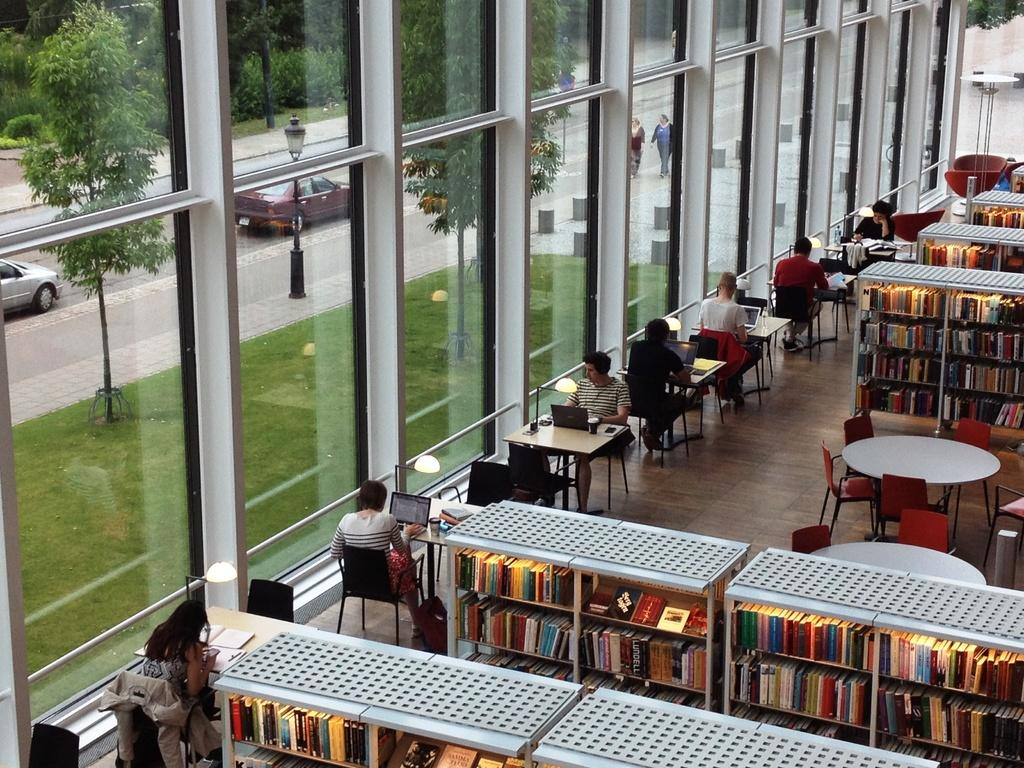What are the people in the image doing? The people in the image are sitting on chairs in front of a table. What can be seen on the road in the image? There are cars on the road in the image. What type of vegetation is present on the ground in the image? There are trees on the ground in the image. What type of books are being sorted on the table in the image? There are no books present in the image; the people are sitting on chairs in front of a table, and there are cars on the road and trees on the ground. 